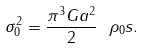Convert formula to latex. <formula><loc_0><loc_0><loc_500><loc_500>\sigma _ { 0 } ^ { 2 } = \frac { \pi ^ { 3 } G a ^ { 2 } } { 2 } \ \rho _ { 0 } s .</formula> 